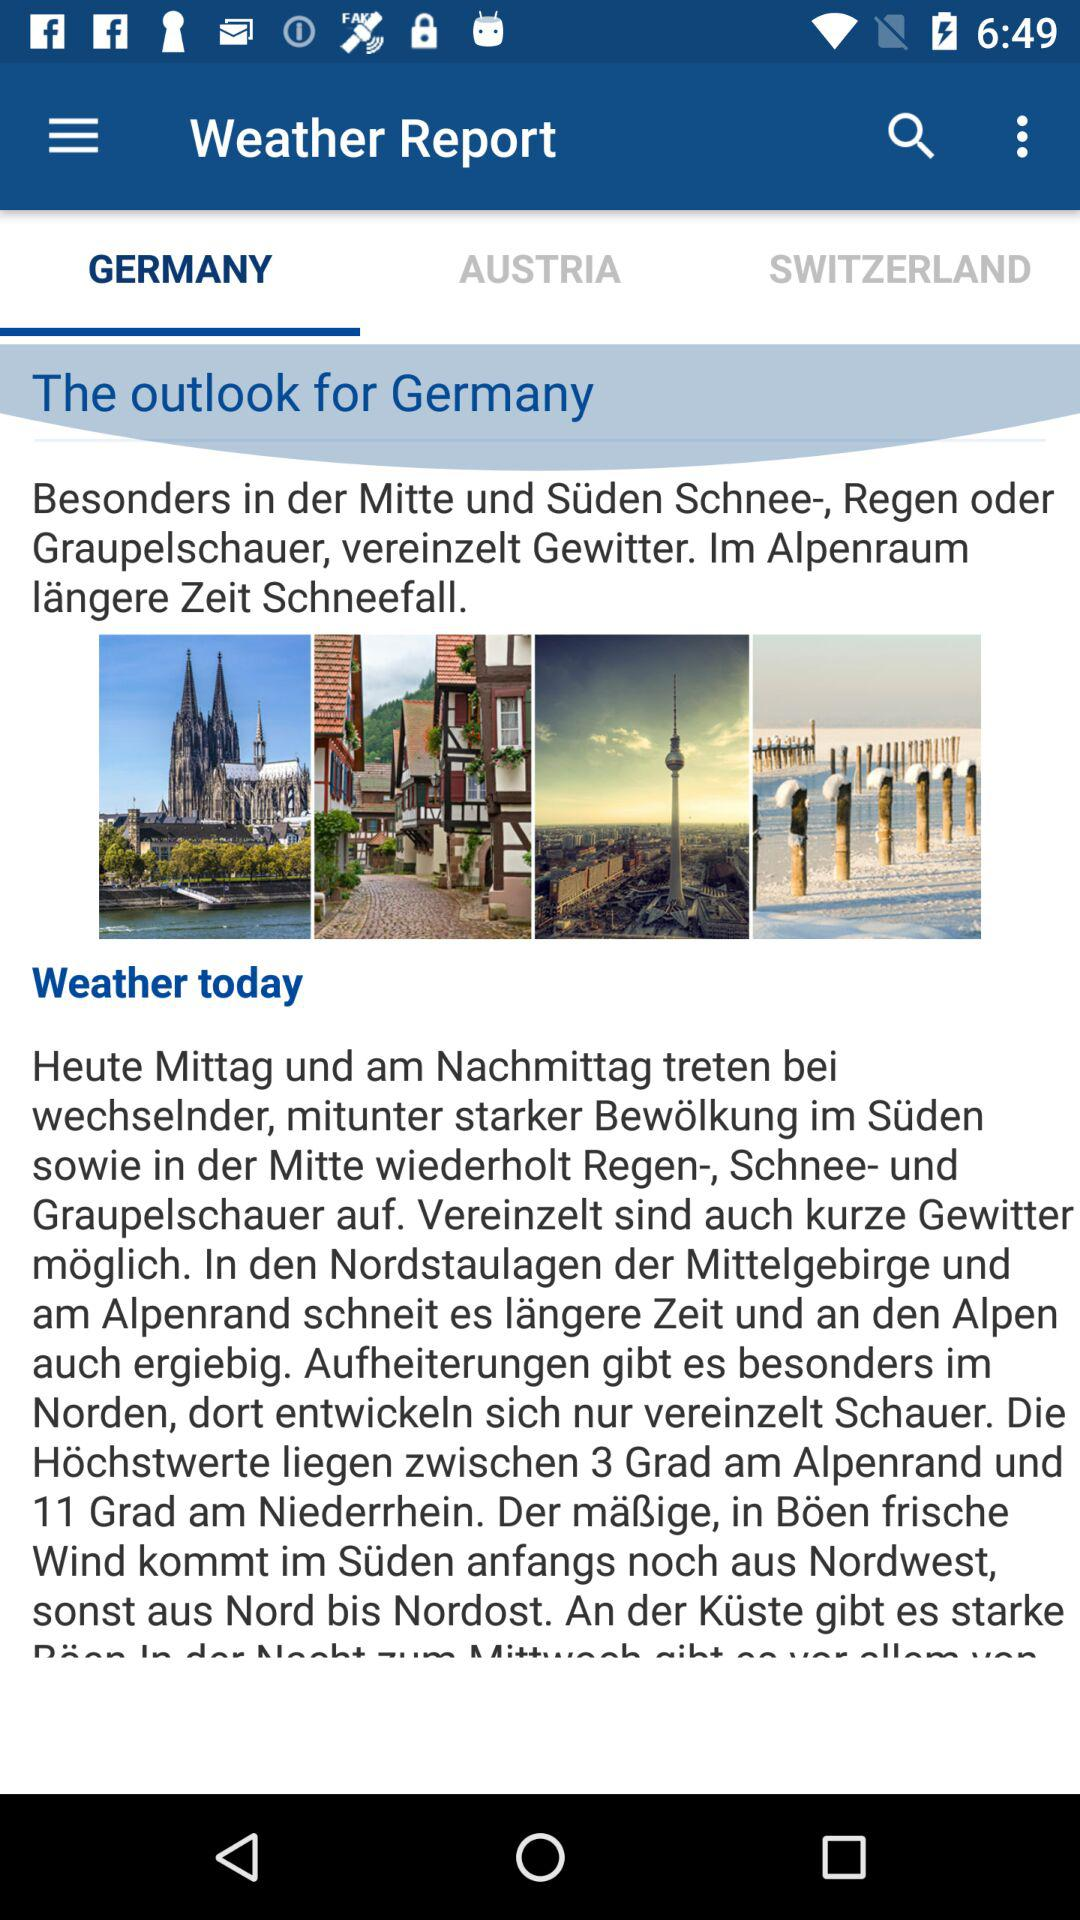Which tab am I on? You are on the "GERMANY" tab. 